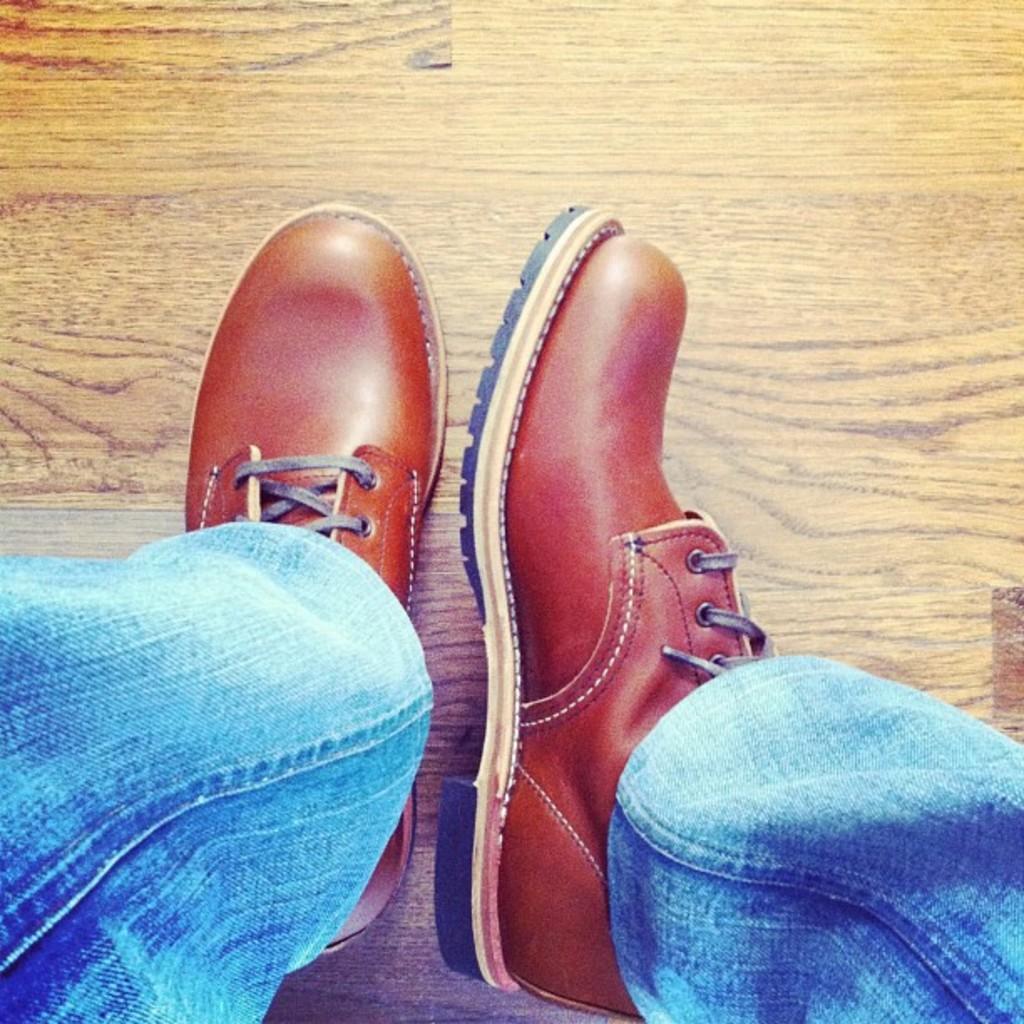Can you describe this image briefly? In this image we can see shares of a person. 